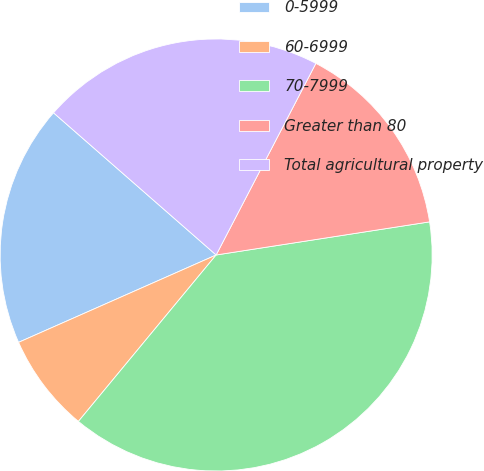<chart> <loc_0><loc_0><loc_500><loc_500><pie_chart><fcel>0-5999<fcel>60-6999<fcel>70-7999<fcel>Greater than 80<fcel>Total agricultural property<nl><fcel>18.06%<fcel>7.37%<fcel>38.45%<fcel>14.91%<fcel>21.2%<nl></chart> 